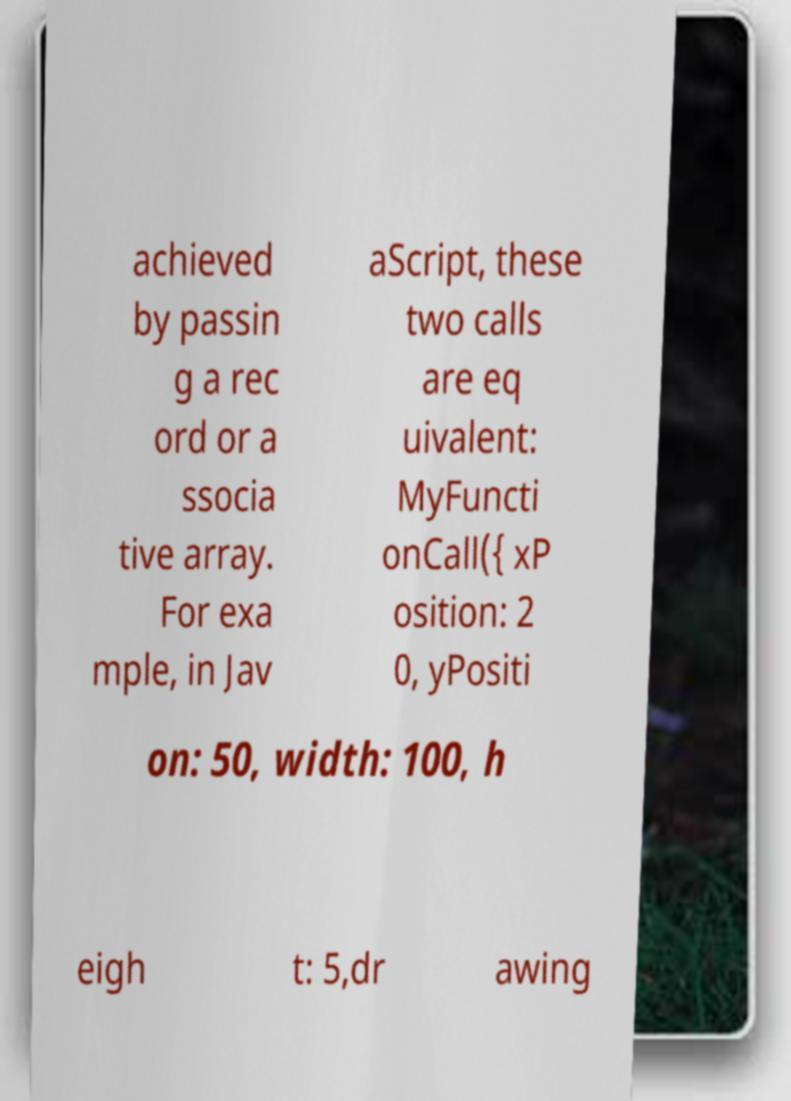Can you read and provide the text displayed in the image?This photo seems to have some interesting text. Can you extract and type it out for me? achieved by passin g a rec ord or a ssocia tive array. For exa mple, in Jav aScript, these two calls are eq uivalent: MyFuncti onCall({ xP osition: 2 0, yPositi on: 50, width: 100, h eigh t: 5,dr awing 